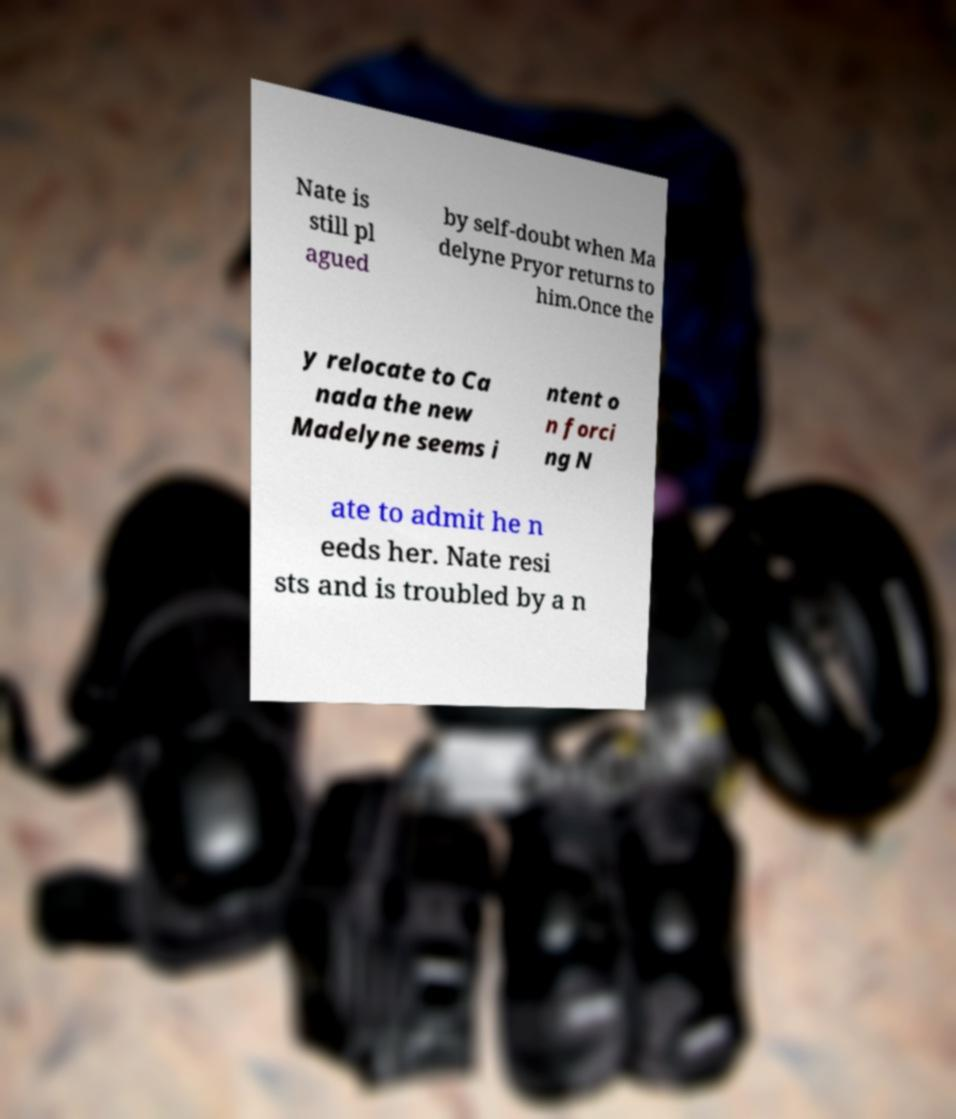There's text embedded in this image that I need extracted. Can you transcribe it verbatim? Nate is still pl agued by self-doubt when Ma delyne Pryor returns to him.Once the y relocate to Ca nada the new Madelyne seems i ntent o n forci ng N ate to admit he n eeds her. Nate resi sts and is troubled by a n 